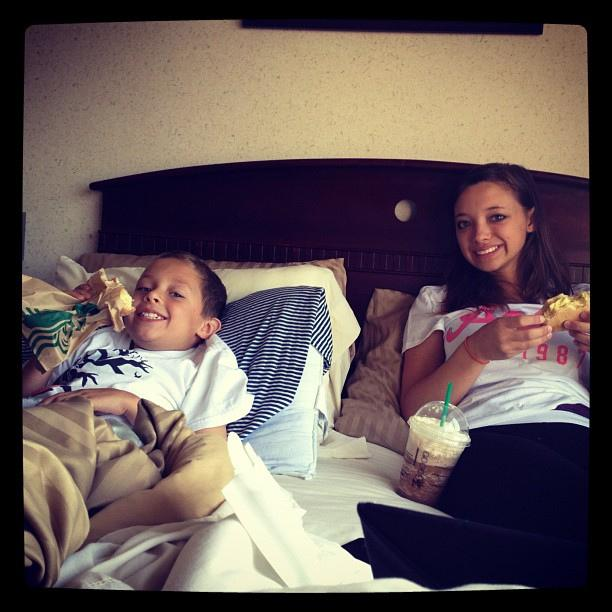What food place did the children get their food from? starbucks 